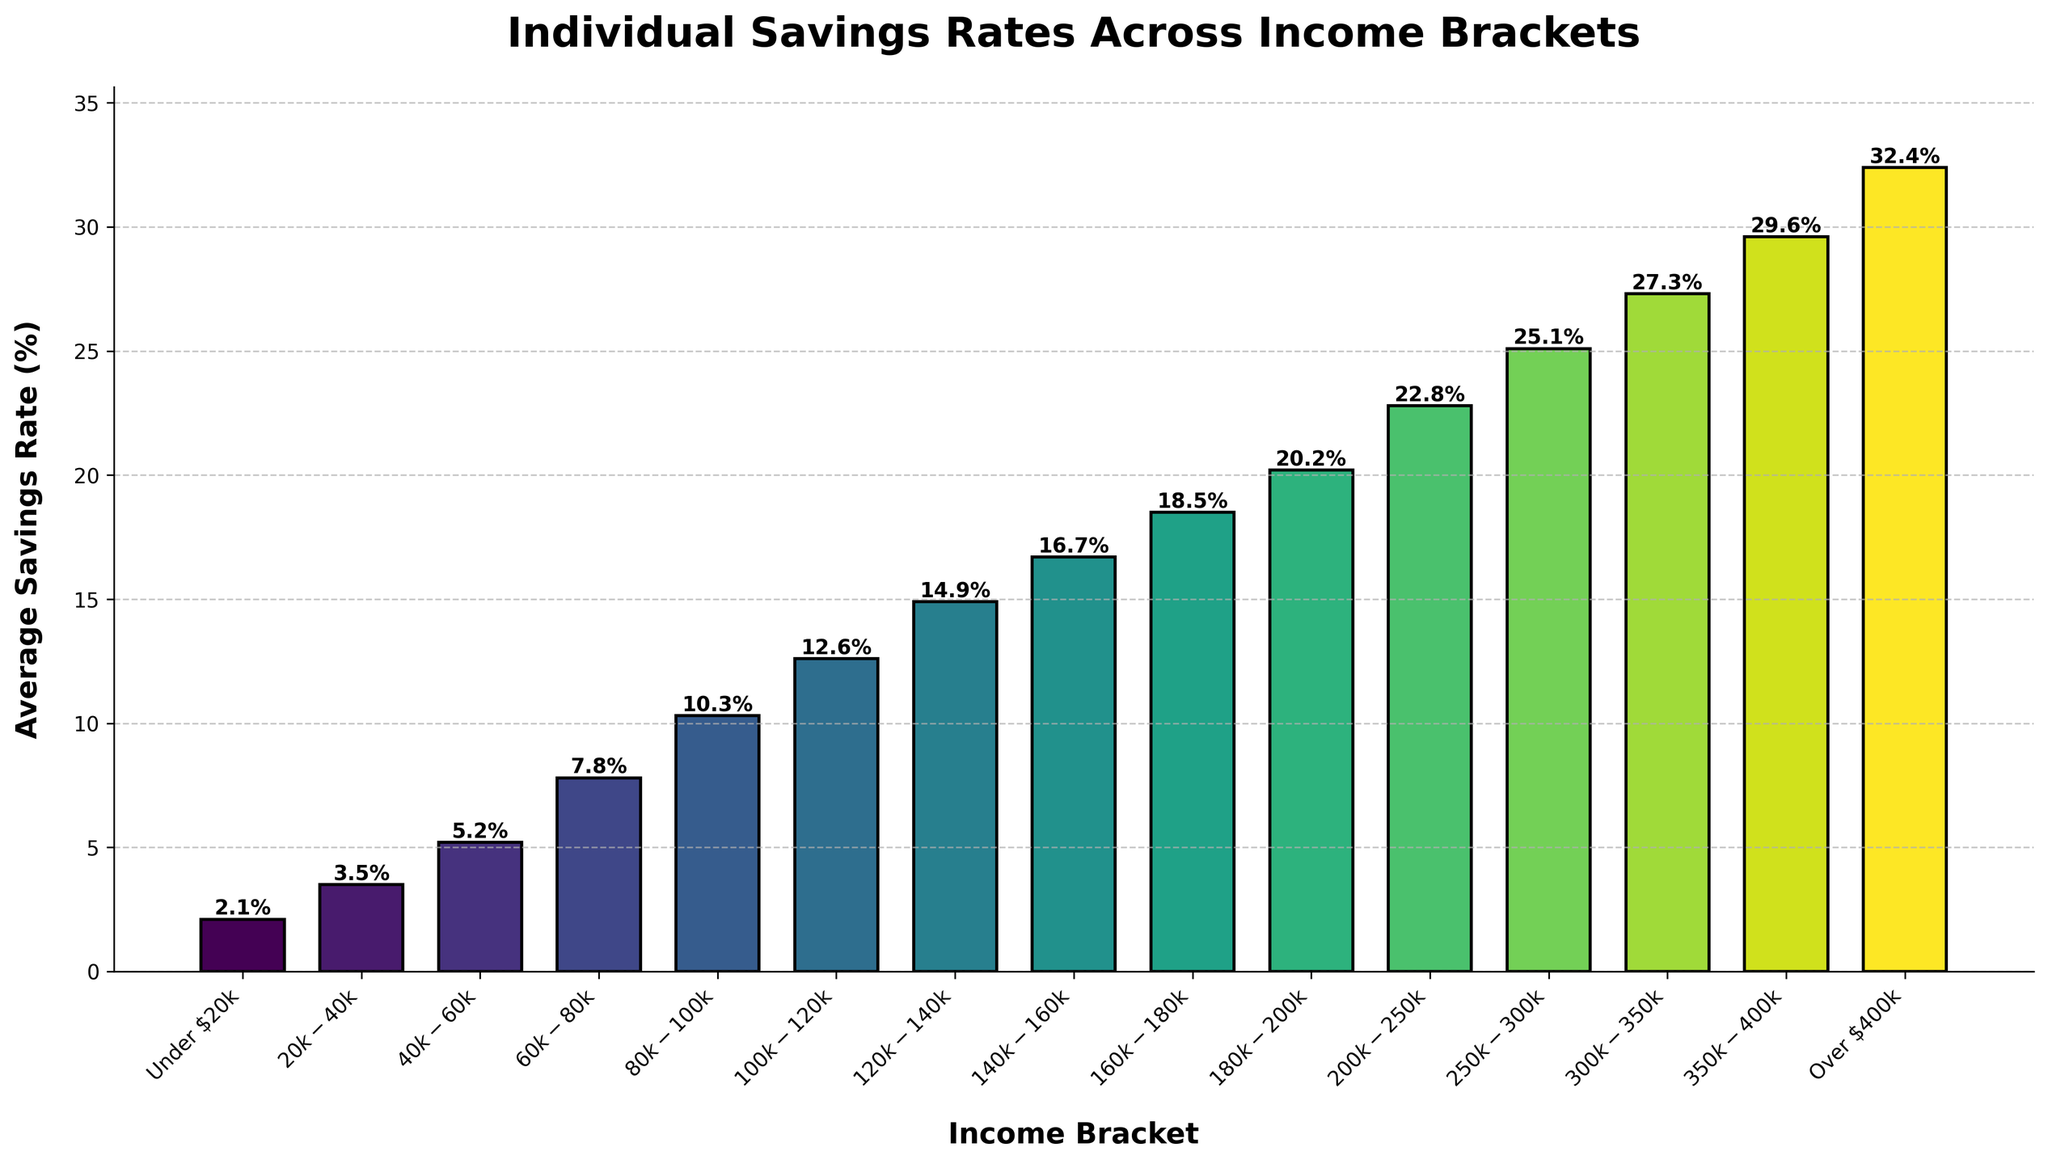What's the median value of individual savings rates? To find the median, list all the savings rates in ascending order and find the middle number. If the number of data points is even, the median is the average of the two middle numbers. Here, there are 15 data points, so the middle one is at the 8th position. The median value is 16.7% because it lies in the exact middle of the dataset.
Answer: 16.7% Between which two income brackets do we see the largest jump in savings rate? To identify this, we look at the difference between successive income brackets' savings rates. The largest jump is from $80k-$100k (10.3%) to $100k-$120k (12.6%), which is a difference of 2.3 percentage points.
Answer: $80k-$100k to $100k-$120k What is the savings rate for the $120k-$140k income bracket, and how does it compare to the $140k-$160k bracket? The savings rate for the $120k-$140k bracket is 14.9%. For the $140k-$160k bracket, it is 16.7%. Comparing the two, the $140k-$160k bracket has a savings rate that is 1.8 percentage points higher than the $120k-$140k bracket.
Answer: 16.7% is 1.8 percentage points higher How much higher is the savings rate for the highest income bracket compared to the lowest? The highest income bracket (Over $400k) has a savings rate of 32.4%, while the lowest (Under $20k) has a savings rate of 2.1%. The difference is 32.4% - 2.1% = 30.3 percentage points.
Answer: 30.3 percentage points What trend do you observe in savings rates as income increases? As income increases, savings rates also increase consistently. This is evident from the fact that each subsequent income bracket has a higher average savings rate, showing a positive correlation between income and savings rates.
Answer: Consistent increase Which income bracket has an average savings rate closest to 10%? The bracket with an average savings rate closest to 10% is $80k-$100k, which has a savings rate of 10.3%.
Answer: $80k-$100k If an individual's savings rate is 22.8%, which income bracket might they belong to? Looking at the chart, the savings rate of 22.8% corresponds to the $200k-$250k income bracket.
Answer: $200k-$250k Between the $60k-$80k and the $80k-$100k income brackets, how much does the average savings rate increase? The average savings rate increases from 7.8% in the $60k-$80k bracket to 10.3% in the $80k-$100k bracket. This is an increase of 10.3% - 7.8% = 2.5 percentage points.
Answer: 2.5 percentage points 